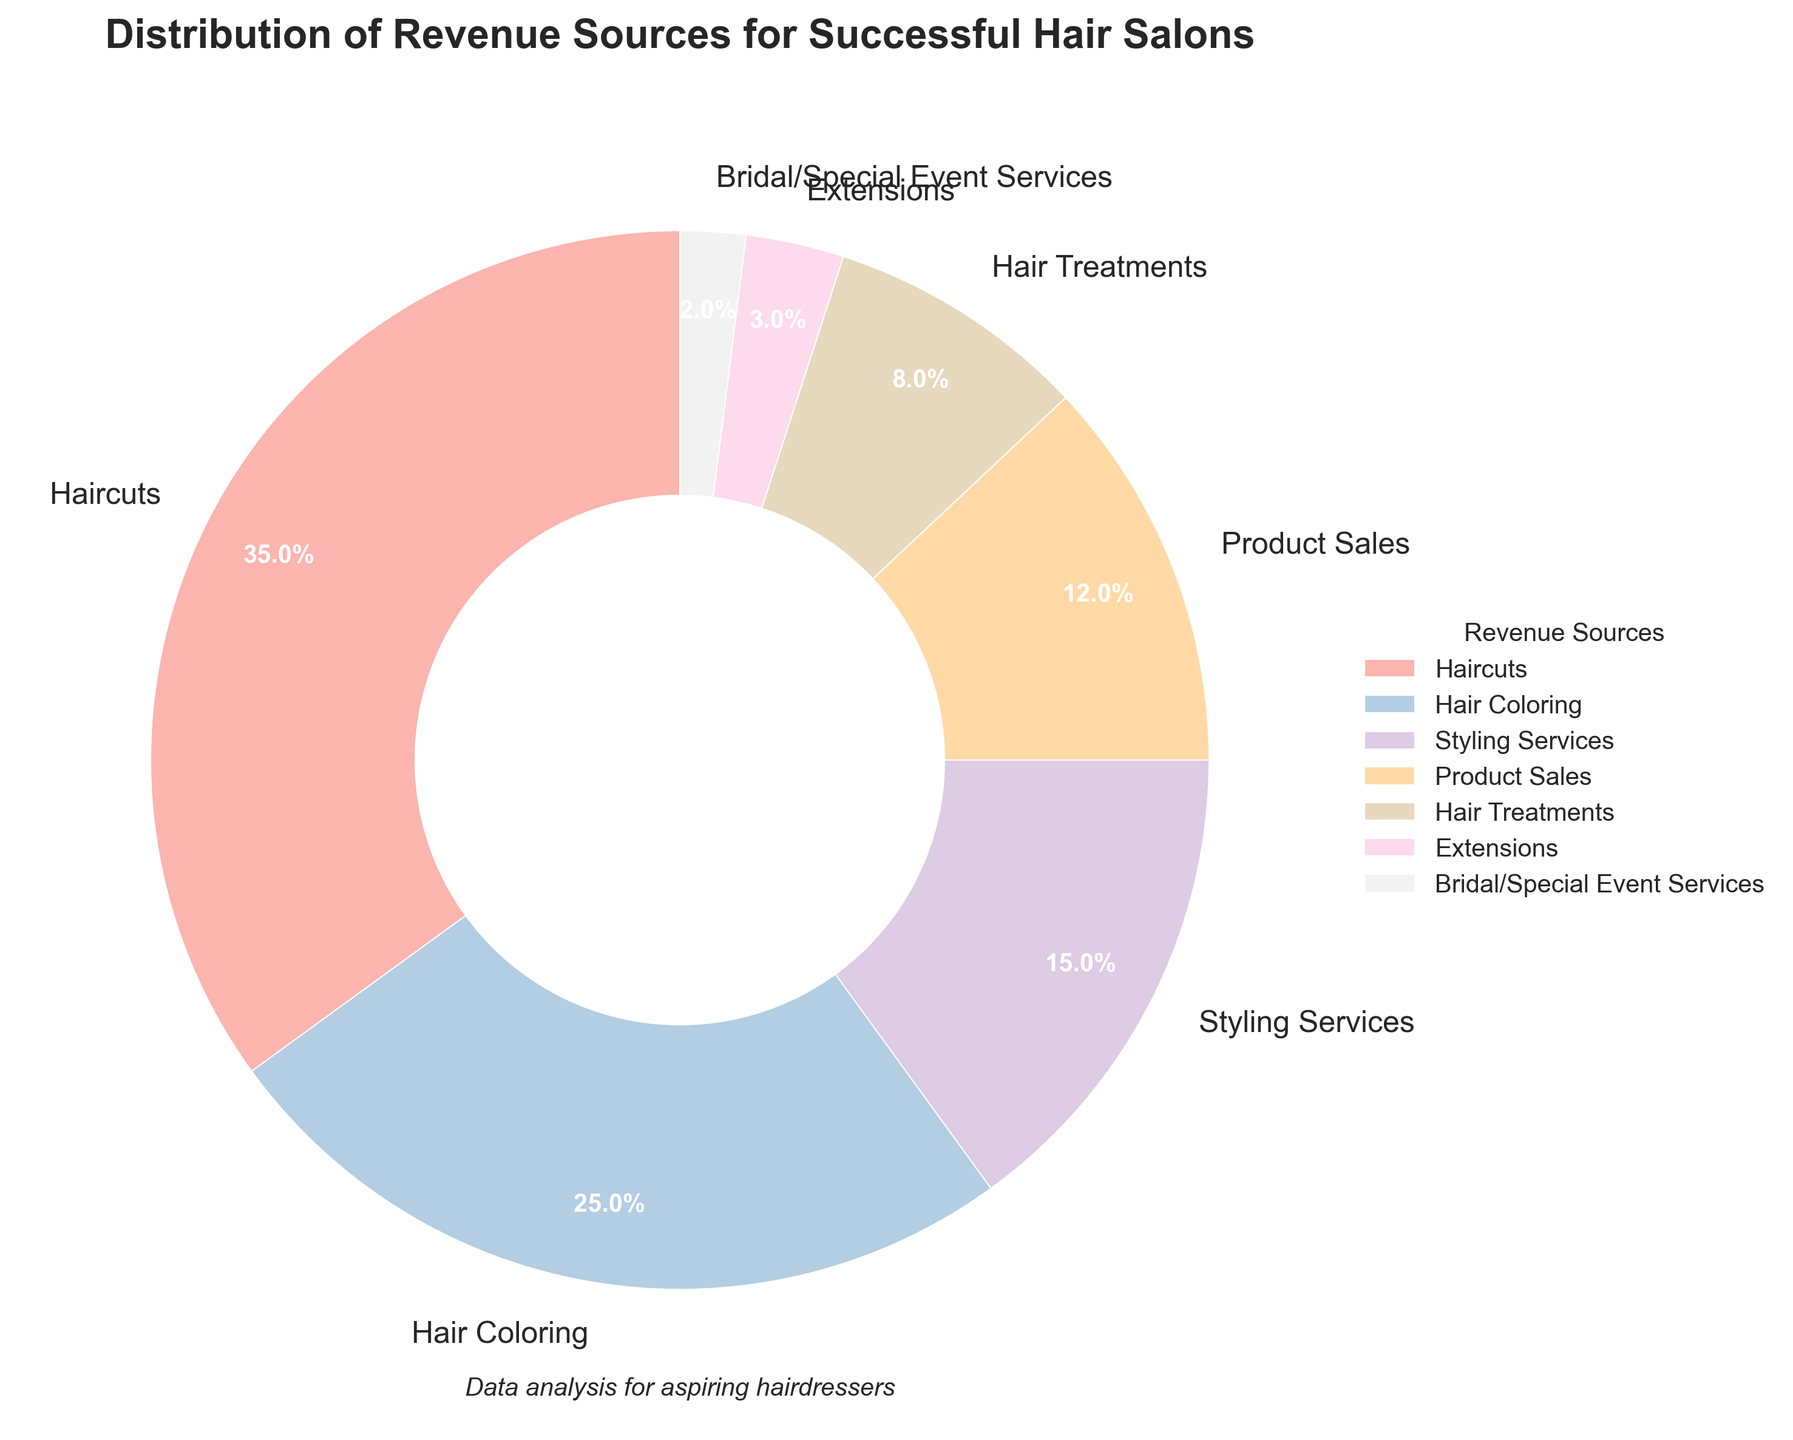What is the most significant revenue source for successful hair salons? To identify the most significant revenue source, look for the segment with the largest percentage in the pie chart. The "Haircuts" segment has the largest wedge.
Answer: Haircuts Which revenue source contributes the least to the total revenue? To find the least contributing revenue source, identify the smallest wedge in the pie chart. The "Bridal/Special Event Services" segment has the smallest wedge.
Answer: Bridal/Special Event Services What is the total percentage of revenue made up by Hair Coloring and Hair Treatments combined? Sum the percentages of the "Hair Coloring" and "Hair Treatments" segments in the pie chart. "Hair Coloring" is 25%, and "Hair Treatments" is 8%, so 25% + 8% = 33%.
Answer: 33% By how many percentage points does the revenue from Haircuts exceed the revenue from Product Sales? Subtract the percentage of "Product Sales" from the percentage of "Haircuts". "Haircuts" is 35%, and "Product Sales" is 12%, so 35% - 12% = 23%.
Answer: 23% What percentage of revenue do Styling Services and Product Sales contribute together? Sum the percentages of "Styling Services" and "Product Sales". "Styling Services" is 15%, and "Product Sales" is 12%, so 15% + 12% = 27%.
Answer: 27% Which revenue source is depicted in pink, and what percentage does it contribute? Look at the pie chart and identify the color pink. The label near the pink segment corresponds to the "Hair Coloring" segment, which contributes 25%.
Answer: Hair Coloring, 25% What is the combined revenue percentage for Extensions and Bridal/Special Event Services? Sum the percentages of "Extensions" and "Bridal/Special Event Services". "Extensions" is 3%, and "Bridal/Special Event Services" is 2%, so 3% + 2% = 5%.
Answer: 5% How does the contribution of Hair Treatments compare to Styling Services in terms of percentage? Compare the percentages of "Hair Treatments" and "Styling Services". "Hair Treatments" is 8%, and "Styling Services" is 15%. Thus, "Hair Treatments" contributes less than "Styling Services".
Answer: Less 